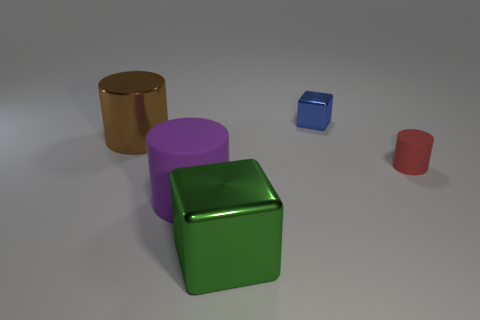Do the big rubber cylinder and the tiny shiny cube have the same color?
Make the answer very short. No. Is there another object that has the same size as the green object?
Your answer should be compact. Yes. What number of metallic objects are either big purple objects or small green objects?
Your answer should be compact. 0. How many yellow shiny blocks are there?
Provide a short and direct response. 0. Does the block behind the large green metallic thing have the same material as the object that is in front of the large purple thing?
Provide a succinct answer. Yes. What is the size of the green object that is the same material as the brown cylinder?
Your answer should be very brief. Large. There is a shiny thing right of the green metallic cube; what is its shape?
Offer a terse response. Cube. Are any cyan metallic cylinders visible?
Make the answer very short. No. There is a shiny thing that is on the right side of the large object right of the matte object left of the large green metal block; what shape is it?
Offer a terse response. Cube. There is a large block; how many purple matte cylinders are behind it?
Provide a short and direct response. 1. 